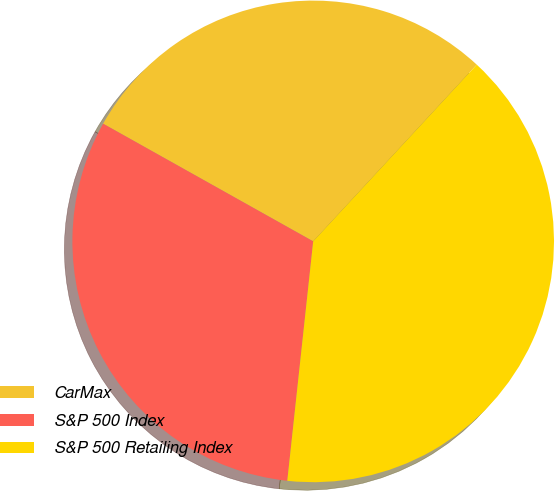Convert chart. <chart><loc_0><loc_0><loc_500><loc_500><pie_chart><fcel>CarMax<fcel>S&P 500 Index<fcel>S&P 500 Retailing Index<nl><fcel>28.76%<fcel>31.41%<fcel>39.83%<nl></chart> 